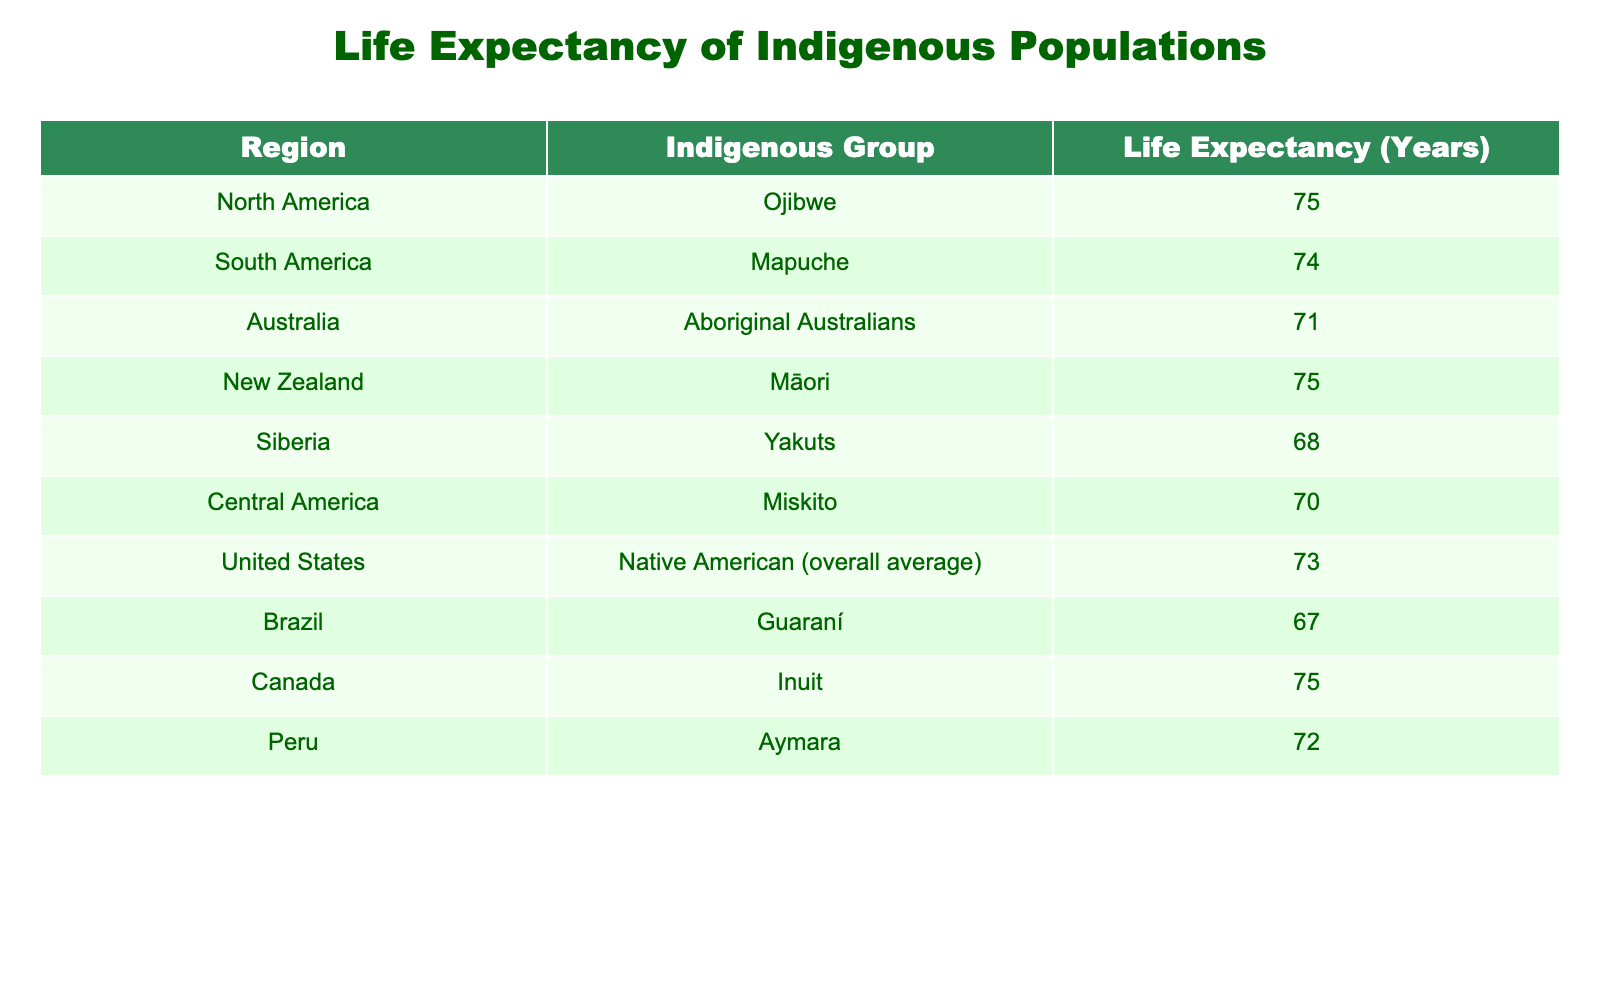What is the life expectancy of the Aboriginal Australians? The table directly states that the life expectancy of Aboriginal Australians is 71 years.
Answer: 71 Which indigenous group has the lowest life expectancy? The table shows that the Guaraní from Brazil has the lowest life expectancy at 67 years.
Answer: Guaraní What is the average life expectancy of the indigenous populations in North America? The table provides the life expectancies for three groups: Ojibwe (75), Native American overall (73), and Inuit (75). Adding these gives 75 + 73 + 75 = 223, and then dividing by 3 results in an average of 74.33.
Answer: 74.33 Does the life expectancy of the Māori equal that of the Ojibwe? The life expectancy for Māori is 75 years, which is the same as Ojibwe, according to the table.
Answer: Yes How does the life expectancy of the Miskito compare to that of the Yakuts? The Miskito's life expectancy is 70 years while Yakuts is 68 years. Therefore, Miskito lives longer than Yakuts by 2 years.
Answer: Miskito is longer by 2 years What is the difference in life expectancy between the Guaraní and the Aymara? The Guaraní has a life expectancy of 67 years and Aymara has 72 years. The difference is calculated by subtracting 67 from 72, which equals 5 years.
Answer: 5 years Are the life expectancies for Inuit and Māori the same? The table shows both Inuit and Māori have a life expectancy of 75 years. Therefore, they are the same.
Answer: Yes Which region has the indigenous group with the second highest life expectancy, and what is that expectancy? The table indicates that both Inuit and Māori have the highest at 75, while the second highest is Ojibwe with 75 as well. Since multiple groups share the top value, the second highest is Miskito with 70. Thus, it's in the Central America region with 70 years.
Answer: Central America, 70 years What would be the median life expectancy of the groups listed in the table? To find the median, we first list the life expectancies in ascending order: 67 (Guaraní), 68 (Yakuts), 70 (Miskito), 71 (Aboriginal Australians), 72 (Aymara), 73 (Native American), 74 (Mapuche), 75 (Ojibwe), 75 (Inuit), 75 (Māori). There are 10 values, and the median is the average of the 5th and 6th values, which are 72 and 73. Thus, (72 + 73) / 2 = 72.5.
Answer: 72.5 